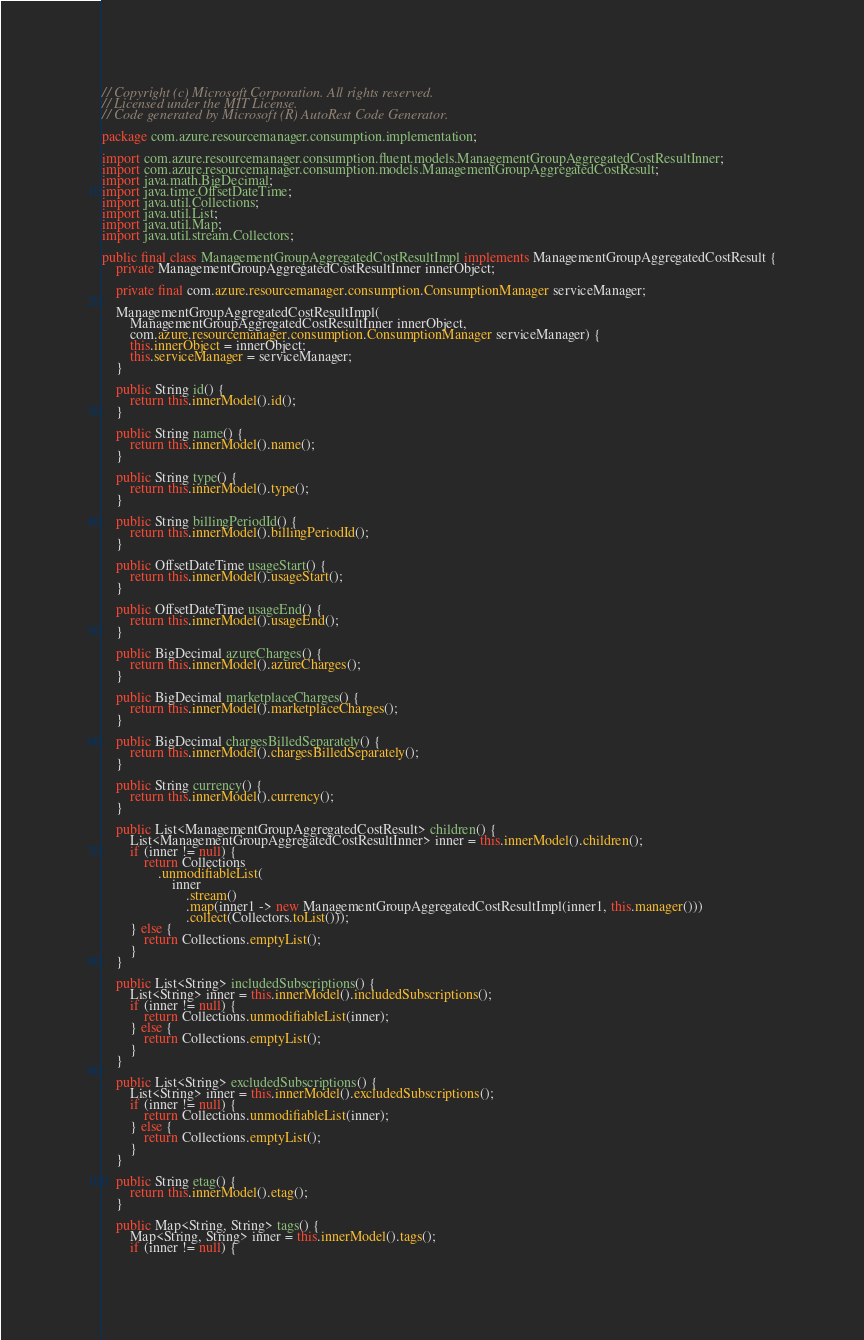<code> <loc_0><loc_0><loc_500><loc_500><_Java_>// Copyright (c) Microsoft Corporation. All rights reserved.
// Licensed under the MIT License.
// Code generated by Microsoft (R) AutoRest Code Generator.

package com.azure.resourcemanager.consumption.implementation;

import com.azure.resourcemanager.consumption.fluent.models.ManagementGroupAggregatedCostResultInner;
import com.azure.resourcemanager.consumption.models.ManagementGroupAggregatedCostResult;
import java.math.BigDecimal;
import java.time.OffsetDateTime;
import java.util.Collections;
import java.util.List;
import java.util.Map;
import java.util.stream.Collectors;

public final class ManagementGroupAggregatedCostResultImpl implements ManagementGroupAggregatedCostResult {
    private ManagementGroupAggregatedCostResultInner innerObject;

    private final com.azure.resourcemanager.consumption.ConsumptionManager serviceManager;

    ManagementGroupAggregatedCostResultImpl(
        ManagementGroupAggregatedCostResultInner innerObject,
        com.azure.resourcemanager.consumption.ConsumptionManager serviceManager) {
        this.innerObject = innerObject;
        this.serviceManager = serviceManager;
    }

    public String id() {
        return this.innerModel().id();
    }

    public String name() {
        return this.innerModel().name();
    }

    public String type() {
        return this.innerModel().type();
    }

    public String billingPeriodId() {
        return this.innerModel().billingPeriodId();
    }

    public OffsetDateTime usageStart() {
        return this.innerModel().usageStart();
    }

    public OffsetDateTime usageEnd() {
        return this.innerModel().usageEnd();
    }

    public BigDecimal azureCharges() {
        return this.innerModel().azureCharges();
    }

    public BigDecimal marketplaceCharges() {
        return this.innerModel().marketplaceCharges();
    }

    public BigDecimal chargesBilledSeparately() {
        return this.innerModel().chargesBilledSeparately();
    }

    public String currency() {
        return this.innerModel().currency();
    }

    public List<ManagementGroupAggregatedCostResult> children() {
        List<ManagementGroupAggregatedCostResultInner> inner = this.innerModel().children();
        if (inner != null) {
            return Collections
                .unmodifiableList(
                    inner
                        .stream()
                        .map(inner1 -> new ManagementGroupAggregatedCostResultImpl(inner1, this.manager()))
                        .collect(Collectors.toList()));
        } else {
            return Collections.emptyList();
        }
    }

    public List<String> includedSubscriptions() {
        List<String> inner = this.innerModel().includedSubscriptions();
        if (inner != null) {
            return Collections.unmodifiableList(inner);
        } else {
            return Collections.emptyList();
        }
    }

    public List<String> excludedSubscriptions() {
        List<String> inner = this.innerModel().excludedSubscriptions();
        if (inner != null) {
            return Collections.unmodifiableList(inner);
        } else {
            return Collections.emptyList();
        }
    }

    public String etag() {
        return this.innerModel().etag();
    }

    public Map<String, String> tags() {
        Map<String, String> inner = this.innerModel().tags();
        if (inner != null) {</code> 